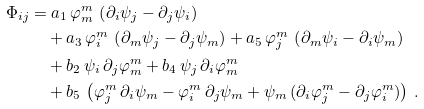<formula> <loc_0><loc_0><loc_500><loc_500>\Phi _ { i j } & = a _ { 1 } \, \varphi ^ { m } _ { m } \, \left ( \partial _ { i } \psi _ { j } - \partial _ { j } \psi _ { i } \right ) \\ & \quad + a _ { 3 } \, \varphi ^ { m } _ { i } \, \left ( \partial _ { m } \psi _ { j } - \partial _ { j } \psi _ { m } \right ) + a _ { 5 } \, \varphi ^ { m } _ { j } \, \left ( \partial _ { m } \psi _ { i } - \partial _ { i } \psi _ { m } \right ) \\ & \quad + b _ { 2 } \, \psi _ { i } \, \partial _ { j } \varphi ^ { m } _ { m } + b _ { 4 } \, \psi _ { j } \, \partial _ { i } \varphi ^ { m } _ { m } \\ & \quad + b _ { 5 } \, \left ( \varphi ^ { m } _ { j } \, \partial _ { i } \psi _ { m } - \varphi ^ { m } _ { i } \, \partial _ { j } \psi _ { m } + \psi _ { m } \, ( \partial _ { i } \varphi ^ { m } _ { j } - \partial _ { j } \varphi ^ { m } _ { i } ) \right ) \, .</formula> 